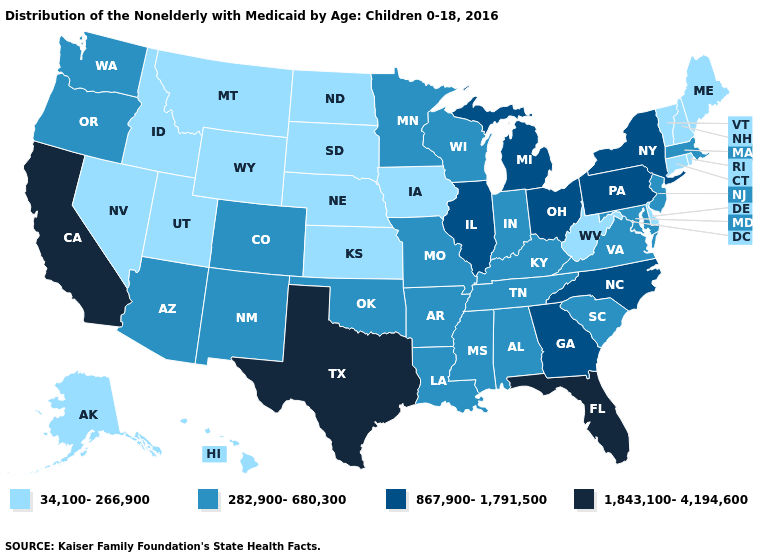How many symbols are there in the legend?
Answer briefly. 4. What is the value of Oregon?
Short answer required. 282,900-680,300. Name the states that have a value in the range 34,100-266,900?
Quick response, please. Alaska, Connecticut, Delaware, Hawaii, Idaho, Iowa, Kansas, Maine, Montana, Nebraska, Nevada, New Hampshire, North Dakota, Rhode Island, South Dakota, Utah, Vermont, West Virginia, Wyoming. How many symbols are there in the legend?
Give a very brief answer. 4. What is the highest value in the USA?
Give a very brief answer. 1,843,100-4,194,600. Does the map have missing data?
Give a very brief answer. No. Name the states that have a value in the range 34,100-266,900?
Keep it brief. Alaska, Connecticut, Delaware, Hawaii, Idaho, Iowa, Kansas, Maine, Montana, Nebraska, Nevada, New Hampshire, North Dakota, Rhode Island, South Dakota, Utah, Vermont, West Virginia, Wyoming. Does South Carolina have a higher value than South Dakota?
Be succinct. Yes. Among the states that border Florida , does Georgia have the highest value?
Concise answer only. Yes. Name the states that have a value in the range 1,843,100-4,194,600?
Concise answer only. California, Florida, Texas. Which states hav the highest value in the Northeast?
Write a very short answer. New York, Pennsylvania. What is the lowest value in the MidWest?
Concise answer only. 34,100-266,900. Name the states that have a value in the range 34,100-266,900?
Answer briefly. Alaska, Connecticut, Delaware, Hawaii, Idaho, Iowa, Kansas, Maine, Montana, Nebraska, Nevada, New Hampshire, North Dakota, Rhode Island, South Dakota, Utah, Vermont, West Virginia, Wyoming. Name the states that have a value in the range 282,900-680,300?
Be succinct. Alabama, Arizona, Arkansas, Colorado, Indiana, Kentucky, Louisiana, Maryland, Massachusetts, Minnesota, Mississippi, Missouri, New Jersey, New Mexico, Oklahoma, Oregon, South Carolina, Tennessee, Virginia, Washington, Wisconsin. 